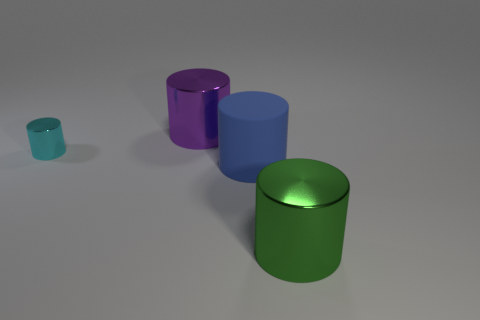What number of other things are the same shape as the cyan thing?
Offer a very short reply. 3. Is the material of the cyan thing the same as the large green cylinder?
Provide a short and direct response. Yes. How many objects are big cyan metal blocks or cylinders?
Keep it short and to the point. 4. The purple shiny object has what size?
Your answer should be compact. Large. Are there fewer tiny purple blocks than tiny shiny cylinders?
Ensure brevity in your answer.  Yes. There is a thing that is behind the small cyan cylinder; is there a cylinder right of it?
Give a very brief answer. Yes. What number of other blue cylinders are made of the same material as the big blue cylinder?
Make the answer very short. 0. What size is the cyan metal thing that is on the left side of the large matte cylinder in front of the thing that is behind the tiny cyan thing?
Your answer should be compact. Small. What number of small cyan metal things are right of the cyan cylinder?
Ensure brevity in your answer.  0. Is the number of big blue rubber things greater than the number of big cylinders?
Keep it short and to the point. No. 